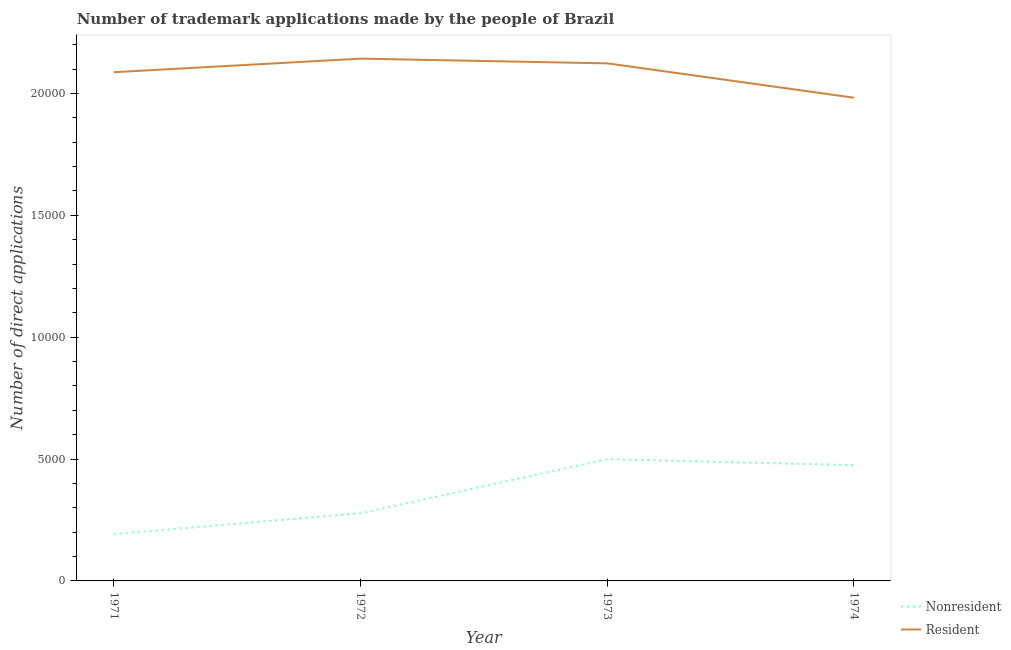How many different coloured lines are there?
Make the answer very short. 2. Is the number of lines equal to the number of legend labels?
Your response must be concise. Yes. What is the number of trademark applications made by residents in 1974?
Give a very brief answer. 1.98e+04. Across all years, what is the maximum number of trademark applications made by residents?
Your response must be concise. 2.14e+04. Across all years, what is the minimum number of trademark applications made by residents?
Ensure brevity in your answer.  1.98e+04. In which year was the number of trademark applications made by non residents maximum?
Give a very brief answer. 1973. In which year was the number of trademark applications made by non residents minimum?
Make the answer very short. 1971. What is the total number of trademark applications made by residents in the graph?
Offer a terse response. 8.34e+04. What is the difference between the number of trademark applications made by non residents in 1972 and that in 1974?
Your answer should be compact. -1973. What is the difference between the number of trademark applications made by residents in 1974 and the number of trademark applications made by non residents in 1972?
Ensure brevity in your answer.  1.70e+04. What is the average number of trademark applications made by non residents per year?
Offer a very short reply. 3609.5. In the year 1974, what is the difference between the number of trademark applications made by residents and number of trademark applications made by non residents?
Ensure brevity in your answer.  1.51e+04. What is the ratio of the number of trademark applications made by residents in 1972 to that in 1973?
Your answer should be very brief. 1.01. Is the number of trademark applications made by non residents in 1972 less than that in 1974?
Ensure brevity in your answer.  Yes. What is the difference between the highest and the second highest number of trademark applications made by residents?
Provide a short and direct response. 193. What is the difference between the highest and the lowest number of trademark applications made by residents?
Your answer should be compact. 1603. In how many years, is the number of trademark applications made by non residents greater than the average number of trademark applications made by non residents taken over all years?
Offer a very short reply. 2. Does the number of trademark applications made by non residents monotonically increase over the years?
Offer a very short reply. No. Is the number of trademark applications made by residents strictly less than the number of trademark applications made by non residents over the years?
Provide a short and direct response. No. How many lines are there?
Give a very brief answer. 2. How many years are there in the graph?
Ensure brevity in your answer.  4. Does the graph contain any zero values?
Your answer should be compact. No. Does the graph contain grids?
Give a very brief answer. No. What is the title of the graph?
Make the answer very short. Number of trademark applications made by the people of Brazil. What is the label or title of the X-axis?
Provide a succinct answer. Year. What is the label or title of the Y-axis?
Make the answer very short. Number of direct applications. What is the Number of direct applications in Nonresident in 1971?
Offer a terse response. 1921. What is the Number of direct applications in Resident in 1971?
Offer a very short reply. 2.09e+04. What is the Number of direct applications of Nonresident in 1972?
Give a very brief answer. 2775. What is the Number of direct applications of Resident in 1972?
Your answer should be compact. 2.14e+04. What is the Number of direct applications of Nonresident in 1973?
Offer a very short reply. 4994. What is the Number of direct applications in Resident in 1973?
Offer a very short reply. 2.12e+04. What is the Number of direct applications of Nonresident in 1974?
Your response must be concise. 4748. What is the Number of direct applications in Resident in 1974?
Ensure brevity in your answer.  1.98e+04. Across all years, what is the maximum Number of direct applications of Nonresident?
Your answer should be very brief. 4994. Across all years, what is the maximum Number of direct applications in Resident?
Keep it short and to the point. 2.14e+04. Across all years, what is the minimum Number of direct applications in Nonresident?
Provide a short and direct response. 1921. Across all years, what is the minimum Number of direct applications of Resident?
Your response must be concise. 1.98e+04. What is the total Number of direct applications of Nonresident in the graph?
Make the answer very short. 1.44e+04. What is the total Number of direct applications of Resident in the graph?
Make the answer very short. 8.34e+04. What is the difference between the Number of direct applications in Nonresident in 1971 and that in 1972?
Your answer should be very brief. -854. What is the difference between the Number of direct applications in Resident in 1971 and that in 1972?
Offer a very short reply. -556. What is the difference between the Number of direct applications in Nonresident in 1971 and that in 1973?
Provide a succinct answer. -3073. What is the difference between the Number of direct applications of Resident in 1971 and that in 1973?
Ensure brevity in your answer.  -363. What is the difference between the Number of direct applications in Nonresident in 1971 and that in 1974?
Provide a short and direct response. -2827. What is the difference between the Number of direct applications in Resident in 1971 and that in 1974?
Your answer should be very brief. 1047. What is the difference between the Number of direct applications of Nonresident in 1972 and that in 1973?
Make the answer very short. -2219. What is the difference between the Number of direct applications in Resident in 1972 and that in 1973?
Your response must be concise. 193. What is the difference between the Number of direct applications of Nonresident in 1972 and that in 1974?
Keep it short and to the point. -1973. What is the difference between the Number of direct applications of Resident in 1972 and that in 1974?
Your response must be concise. 1603. What is the difference between the Number of direct applications of Nonresident in 1973 and that in 1974?
Your response must be concise. 246. What is the difference between the Number of direct applications of Resident in 1973 and that in 1974?
Offer a terse response. 1410. What is the difference between the Number of direct applications in Nonresident in 1971 and the Number of direct applications in Resident in 1972?
Provide a short and direct response. -1.95e+04. What is the difference between the Number of direct applications in Nonresident in 1971 and the Number of direct applications in Resident in 1973?
Keep it short and to the point. -1.93e+04. What is the difference between the Number of direct applications of Nonresident in 1971 and the Number of direct applications of Resident in 1974?
Provide a succinct answer. -1.79e+04. What is the difference between the Number of direct applications in Nonresident in 1972 and the Number of direct applications in Resident in 1973?
Offer a very short reply. -1.85e+04. What is the difference between the Number of direct applications of Nonresident in 1972 and the Number of direct applications of Resident in 1974?
Offer a very short reply. -1.70e+04. What is the difference between the Number of direct applications of Nonresident in 1973 and the Number of direct applications of Resident in 1974?
Your answer should be compact. -1.48e+04. What is the average Number of direct applications in Nonresident per year?
Offer a terse response. 3609.5. What is the average Number of direct applications of Resident per year?
Provide a short and direct response. 2.08e+04. In the year 1971, what is the difference between the Number of direct applications in Nonresident and Number of direct applications in Resident?
Provide a succinct answer. -1.89e+04. In the year 1972, what is the difference between the Number of direct applications in Nonresident and Number of direct applications in Resident?
Provide a short and direct response. -1.87e+04. In the year 1973, what is the difference between the Number of direct applications of Nonresident and Number of direct applications of Resident?
Offer a terse response. -1.62e+04. In the year 1974, what is the difference between the Number of direct applications of Nonresident and Number of direct applications of Resident?
Provide a short and direct response. -1.51e+04. What is the ratio of the Number of direct applications in Nonresident in 1971 to that in 1972?
Your answer should be very brief. 0.69. What is the ratio of the Number of direct applications in Resident in 1971 to that in 1972?
Make the answer very short. 0.97. What is the ratio of the Number of direct applications in Nonresident in 1971 to that in 1973?
Provide a succinct answer. 0.38. What is the ratio of the Number of direct applications in Resident in 1971 to that in 1973?
Your response must be concise. 0.98. What is the ratio of the Number of direct applications in Nonresident in 1971 to that in 1974?
Your answer should be compact. 0.4. What is the ratio of the Number of direct applications of Resident in 1971 to that in 1974?
Make the answer very short. 1.05. What is the ratio of the Number of direct applications of Nonresident in 1972 to that in 1973?
Provide a short and direct response. 0.56. What is the ratio of the Number of direct applications in Resident in 1972 to that in 1973?
Ensure brevity in your answer.  1.01. What is the ratio of the Number of direct applications of Nonresident in 1972 to that in 1974?
Offer a very short reply. 0.58. What is the ratio of the Number of direct applications of Resident in 1972 to that in 1974?
Make the answer very short. 1.08. What is the ratio of the Number of direct applications of Nonresident in 1973 to that in 1974?
Your response must be concise. 1.05. What is the ratio of the Number of direct applications in Resident in 1973 to that in 1974?
Ensure brevity in your answer.  1.07. What is the difference between the highest and the second highest Number of direct applications in Nonresident?
Make the answer very short. 246. What is the difference between the highest and the second highest Number of direct applications in Resident?
Provide a short and direct response. 193. What is the difference between the highest and the lowest Number of direct applications in Nonresident?
Ensure brevity in your answer.  3073. What is the difference between the highest and the lowest Number of direct applications in Resident?
Provide a short and direct response. 1603. 